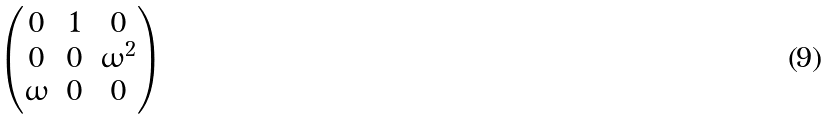<formula> <loc_0><loc_0><loc_500><loc_500>\begin{pmatrix} 0 & 1 & 0 \\ 0 & 0 & \omega ^ { 2 } \\ \omega & 0 & 0 \\ \end{pmatrix}</formula> 